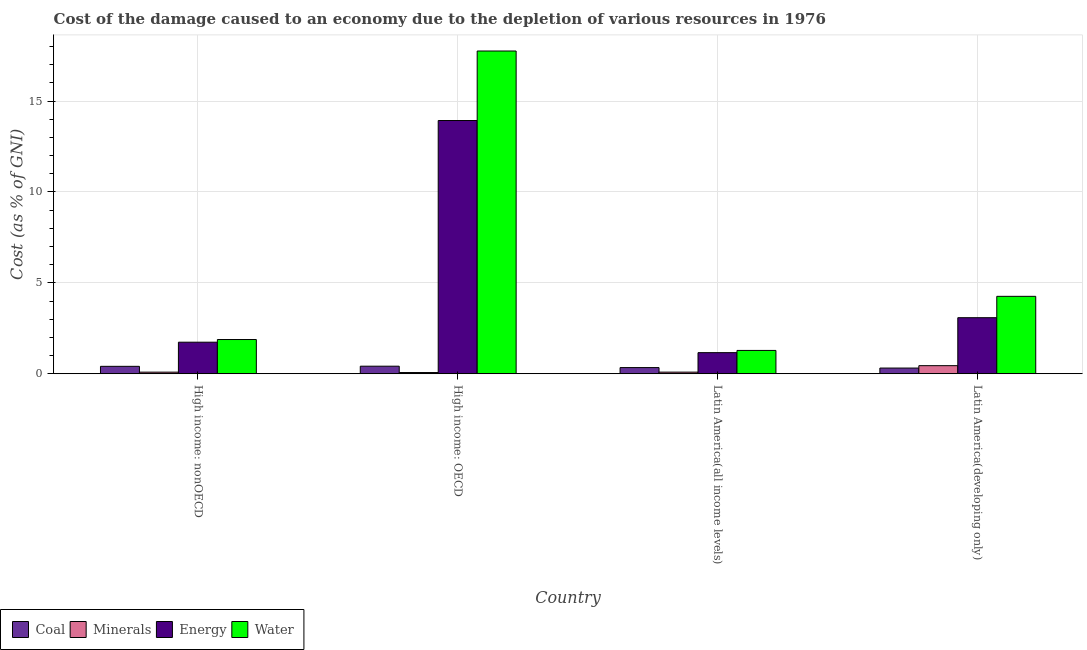How many different coloured bars are there?
Your answer should be very brief. 4. How many bars are there on the 2nd tick from the left?
Keep it short and to the point. 4. What is the label of the 3rd group of bars from the left?
Give a very brief answer. Latin America(all income levels). In how many cases, is the number of bars for a given country not equal to the number of legend labels?
Your answer should be compact. 0. What is the cost of damage due to depletion of water in High income: OECD?
Provide a succinct answer. 17.75. Across all countries, what is the maximum cost of damage due to depletion of minerals?
Ensure brevity in your answer.  0.44. Across all countries, what is the minimum cost of damage due to depletion of energy?
Your response must be concise. 1.16. In which country was the cost of damage due to depletion of coal maximum?
Provide a short and direct response. High income: OECD. In which country was the cost of damage due to depletion of coal minimum?
Give a very brief answer. Latin America(developing only). What is the total cost of damage due to depletion of energy in the graph?
Ensure brevity in your answer.  19.91. What is the difference between the cost of damage due to depletion of energy in High income: nonOECD and that in Latin America(developing only)?
Your answer should be compact. -1.35. What is the difference between the cost of damage due to depletion of energy in High income: OECD and the cost of damage due to depletion of minerals in Latin America(all income levels)?
Ensure brevity in your answer.  13.84. What is the average cost of damage due to depletion of coal per country?
Keep it short and to the point. 0.37. What is the difference between the cost of damage due to depletion of water and cost of damage due to depletion of minerals in High income: OECD?
Provide a succinct answer. 17.69. In how many countries, is the cost of damage due to depletion of water greater than 3 %?
Give a very brief answer. 2. What is the ratio of the cost of damage due to depletion of minerals in High income: OECD to that in Latin America(all income levels)?
Offer a very short reply. 0.74. What is the difference between the highest and the second highest cost of damage due to depletion of energy?
Your answer should be compact. 10.85. What is the difference between the highest and the lowest cost of damage due to depletion of energy?
Give a very brief answer. 12.77. In how many countries, is the cost of damage due to depletion of energy greater than the average cost of damage due to depletion of energy taken over all countries?
Your answer should be very brief. 1. What does the 2nd bar from the left in High income: nonOECD represents?
Your answer should be very brief. Minerals. What does the 4th bar from the right in High income: nonOECD represents?
Ensure brevity in your answer.  Coal. Is it the case that in every country, the sum of the cost of damage due to depletion of coal and cost of damage due to depletion of minerals is greater than the cost of damage due to depletion of energy?
Keep it short and to the point. No. How many countries are there in the graph?
Make the answer very short. 4. Are the values on the major ticks of Y-axis written in scientific E-notation?
Offer a terse response. No. Does the graph contain grids?
Provide a succinct answer. Yes. How are the legend labels stacked?
Your response must be concise. Horizontal. What is the title of the graph?
Offer a very short reply. Cost of the damage caused to an economy due to the depletion of various resources in 1976 . What is the label or title of the Y-axis?
Ensure brevity in your answer.  Cost (as % of GNI). What is the Cost (as % of GNI) of Coal in High income: nonOECD?
Your response must be concise. 0.41. What is the Cost (as % of GNI) in Minerals in High income: nonOECD?
Your answer should be compact. 0.09. What is the Cost (as % of GNI) in Energy in High income: nonOECD?
Your answer should be very brief. 1.73. What is the Cost (as % of GNI) in Water in High income: nonOECD?
Provide a succinct answer. 1.88. What is the Cost (as % of GNI) of Coal in High income: OECD?
Your answer should be very brief. 0.41. What is the Cost (as % of GNI) of Minerals in High income: OECD?
Offer a very short reply. 0.07. What is the Cost (as % of GNI) in Energy in High income: OECD?
Offer a terse response. 13.93. What is the Cost (as % of GNI) of Water in High income: OECD?
Offer a terse response. 17.75. What is the Cost (as % of GNI) in Coal in Latin America(all income levels)?
Keep it short and to the point. 0.34. What is the Cost (as % of GNI) of Minerals in Latin America(all income levels)?
Provide a short and direct response. 0.09. What is the Cost (as % of GNI) of Energy in Latin America(all income levels)?
Provide a short and direct response. 1.16. What is the Cost (as % of GNI) in Water in Latin America(all income levels)?
Make the answer very short. 1.28. What is the Cost (as % of GNI) in Coal in Latin America(developing only)?
Your answer should be compact. 0.31. What is the Cost (as % of GNI) of Minerals in Latin America(developing only)?
Make the answer very short. 0.44. What is the Cost (as % of GNI) in Energy in Latin America(developing only)?
Provide a short and direct response. 3.08. What is the Cost (as % of GNI) in Water in Latin America(developing only)?
Your answer should be compact. 4.26. Across all countries, what is the maximum Cost (as % of GNI) in Coal?
Provide a succinct answer. 0.41. Across all countries, what is the maximum Cost (as % of GNI) in Minerals?
Keep it short and to the point. 0.44. Across all countries, what is the maximum Cost (as % of GNI) of Energy?
Provide a short and direct response. 13.93. Across all countries, what is the maximum Cost (as % of GNI) in Water?
Provide a short and direct response. 17.75. Across all countries, what is the minimum Cost (as % of GNI) of Coal?
Provide a short and direct response. 0.31. Across all countries, what is the minimum Cost (as % of GNI) in Minerals?
Make the answer very short. 0.07. Across all countries, what is the minimum Cost (as % of GNI) of Energy?
Keep it short and to the point. 1.16. Across all countries, what is the minimum Cost (as % of GNI) of Water?
Ensure brevity in your answer.  1.28. What is the total Cost (as % of GNI) of Coal in the graph?
Your response must be concise. 1.47. What is the total Cost (as % of GNI) of Minerals in the graph?
Provide a short and direct response. 0.69. What is the total Cost (as % of GNI) of Energy in the graph?
Give a very brief answer. 19.91. What is the total Cost (as % of GNI) in Water in the graph?
Offer a very short reply. 25.18. What is the difference between the Cost (as % of GNI) of Coal in High income: nonOECD and that in High income: OECD?
Offer a very short reply. -0.01. What is the difference between the Cost (as % of GNI) in Minerals in High income: nonOECD and that in High income: OECD?
Provide a short and direct response. 0.02. What is the difference between the Cost (as % of GNI) in Energy in High income: nonOECD and that in High income: OECD?
Give a very brief answer. -12.19. What is the difference between the Cost (as % of GNI) in Water in High income: nonOECD and that in High income: OECD?
Your answer should be very brief. -15.87. What is the difference between the Cost (as % of GNI) in Coal in High income: nonOECD and that in Latin America(all income levels)?
Offer a very short reply. 0.07. What is the difference between the Cost (as % of GNI) in Minerals in High income: nonOECD and that in Latin America(all income levels)?
Your answer should be compact. -0. What is the difference between the Cost (as % of GNI) of Energy in High income: nonOECD and that in Latin America(all income levels)?
Offer a terse response. 0.57. What is the difference between the Cost (as % of GNI) of Water in High income: nonOECD and that in Latin America(all income levels)?
Make the answer very short. 0.6. What is the difference between the Cost (as % of GNI) in Coal in High income: nonOECD and that in Latin America(developing only)?
Keep it short and to the point. 0.09. What is the difference between the Cost (as % of GNI) in Minerals in High income: nonOECD and that in Latin America(developing only)?
Keep it short and to the point. -0.36. What is the difference between the Cost (as % of GNI) in Energy in High income: nonOECD and that in Latin America(developing only)?
Keep it short and to the point. -1.35. What is the difference between the Cost (as % of GNI) of Water in High income: nonOECD and that in Latin America(developing only)?
Your answer should be very brief. -2.38. What is the difference between the Cost (as % of GNI) in Coal in High income: OECD and that in Latin America(all income levels)?
Give a very brief answer. 0.08. What is the difference between the Cost (as % of GNI) of Minerals in High income: OECD and that in Latin America(all income levels)?
Keep it short and to the point. -0.02. What is the difference between the Cost (as % of GNI) in Energy in High income: OECD and that in Latin America(all income levels)?
Your answer should be very brief. 12.77. What is the difference between the Cost (as % of GNI) of Water in High income: OECD and that in Latin America(all income levels)?
Ensure brevity in your answer.  16.47. What is the difference between the Cost (as % of GNI) in Coal in High income: OECD and that in Latin America(developing only)?
Provide a short and direct response. 0.1. What is the difference between the Cost (as % of GNI) in Minerals in High income: OECD and that in Latin America(developing only)?
Your answer should be very brief. -0.38. What is the difference between the Cost (as % of GNI) of Energy in High income: OECD and that in Latin America(developing only)?
Offer a terse response. 10.85. What is the difference between the Cost (as % of GNI) of Water in High income: OECD and that in Latin America(developing only)?
Your answer should be very brief. 13.5. What is the difference between the Cost (as % of GNI) in Coal in Latin America(all income levels) and that in Latin America(developing only)?
Ensure brevity in your answer.  0.03. What is the difference between the Cost (as % of GNI) of Minerals in Latin America(all income levels) and that in Latin America(developing only)?
Give a very brief answer. -0.36. What is the difference between the Cost (as % of GNI) in Energy in Latin America(all income levels) and that in Latin America(developing only)?
Your answer should be very brief. -1.92. What is the difference between the Cost (as % of GNI) in Water in Latin America(all income levels) and that in Latin America(developing only)?
Make the answer very short. -2.98. What is the difference between the Cost (as % of GNI) of Coal in High income: nonOECD and the Cost (as % of GNI) of Minerals in High income: OECD?
Offer a very short reply. 0.34. What is the difference between the Cost (as % of GNI) of Coal in High income: nonOECD and the Cost (as % of GNI) of Energy in High income: OECD?
Provide a short and direct response. -13.52. What is the difference between the Cost (as % of GNI) in Coal in High income: nonOECD and the Cost (as % of GNI) in Water in High income: OECD?
Provide a short and direct response. -17.35. What is the difference between the Cost (as % of GNI) in Minerals in High income: nonOECD and the Cost (as % of GNI) in Energy in High income: OECD?
Your answer should be very brief. -13.84. What is the difference between the Cost (as % of GNI) in Minerals in High income: nonOECD and the Cost (as % of GNI) in Water in High income: OECD?
Provide a short and direct response. -17.67. What is the difference between the Cost (as % of GNI) in Energy in High income: nonOECD and the Cost (as % of GNI) in Water in High income: OECD?
Offer a very short reply. -16.02. What is the difference between the Cost (as % of GNI) of Coal in High income: nonOECD and the Cost (as % of GNI) of Minerals in Latin America(all income levels)?
Make the answer very short. 0.32. What is the difference between the Cost (as % of GNI) in Coal in High income: nonOECD and the Cost (as % of GNI) in Energy in Latin America(all income levels)?
Ensure brevity in your answer.  -0.75. What is the difference between the Cost (as % of GNI) of Coal in High income: nonOECD and the Cost (as % of GNI) of Water in Latin America(all income levels)?
Offer a terse response. -0.88. What is the difference between the Cost (as % of GNI) in Minerals in High income: nonOECD and the Cost (as % of GNI) in Energy in Latin America(all income levels)?
Give a very brief answer. -1.07. What is the difference between the Cost (as % of GNI) in Minerals in High income: nonOECD and the Cost (as % of GNI) in Water in Latin America(all income levels)?
Offer a very short reply. -1.19. What is the difference between the Cost (as % of GNI) in Energy in High income: nonOECD and the Cost (as % of GNI) in Water in Latin America(all income levels)?
Offer a very short reply. 0.45. What is the difference between the Cost (as % of GNI) of Coal in High income: nonOECD and the Cost (as % of GNI) of Minerals in Latin America(developing only)?
Your answer should be compact. -0.04. What is the difference between the Cost (as % of GNI) in Coal in High income: nonOECD and the Cost (as % of GNI) in Energy in Latin America(developing only)?
Provide a succinct answer. -2.68. What is the difference between the Cost (as % of GNI) of Coal in High income: nonOECD and the Cost (as % of GNI) of Water in Latin America(developing only)?
Offer a very short reply. -3.85. What is the difference between the Cost (as % of GNI) in Minerals in High income: nonOECD and the Cost (as % of GNI) in Energy in Latin America(developing only)?
Offer a terse response. -3. What is the difference between the Cost (as % of GNI) in Minerals in High income: nonOECD and the Cost (as % of GNI) in Water in Latin America(developing only)?
Your answer should be compact. -4.17. What is the difference between the Cost (as % of GNI) in Energy in High income: nonOECD and the Cost (as % of GNI) in Water in Latin America(developing only)?
Your response must be concise. -2.52. What is the difference between the Cost (as % of GNI) of Coal in High income: OECD and the Cost (as % of GNI) of Minerals in Latin America(all income levels)?
Provide a succinct answer. 0.33. What is the difference between the Cost (as % of GNI) in Coal in High income: OECD and the Cost (as % of GNI) in Energy in Latin America(all income levels)?
Provide a short and direct response. -0.75. What is the difference between the Cost (as % of GNI) of Coal in High income: OECD and the Cost (as % of GNI) of Water in Latin America(all income levels)?
Provide a short and direct response. -0.87. What is the difference between the Cost (as % of GNI) in Minerals in High income: OECD and the Cost (as % of GNI) in Energy in Latin America(all income levels)?
Give a very brief answer. -1.09. What is the difference between the Cost (as % of GNI) in Minerals in High income: OECD and the Cost (as % of GNI) in Water in Latin America(all income levels)?
Provide a succinct answer. -1.22. What is the difference between the Cost (as % of GNI) in Energy in High income: OECD and the Cost (as % of GNI) in Water in Latin America(all income levels)?
Offer a very short reply. 12.65. What is the difference between the Cost (as % of GNI) of Coal in High income: OECD and the Cost (as % of GNI) of Minerals in Latin America(developing only)?
Give a very brief answer. -0.03. What is the difference between the Cost (as % of GNI) of Coal in High income: OECD and the Cost (as % of GNI) of Energy in Latin America(developing only)?
Make the answer very short. -2.67. What is the difference between the Cost (as % of GNI) in Coal in High income: OECD and the Cost (as % of GNI) in Water in Latin America(developing only)?
Make the answer very short. -3.84. What is the difference between the Cost (as % of GNI) in Minerals in High income: OECD and the Cost (as % of GNI) in Energy in Latin America(developing only)?
Ensure brevity in your answer.  -3.02. What is the difference between the Cost (as % of GNI) of Minerals in High income: OECD and the Cost (as % of GNI) of Water in Latin America(developing only)?
Keep it short and to the point. -4.19. What is the difference between the Cost (as % of GNI) of Energy in High income: OECD and the Cost (as % of GNI) of Water in Latin America(developing only)?
Make the answer very short. 9.67. What is the difference between the Cost (as % of GNI) of Coal in Latin America(all income levels) and the Cost (as % of GNI) of Minerals in Latin America(developing only)?
Make the answer very short. -0.11. What is the difference between the Cost (as % of GNI) in Coal in Latin America(all income levels) and the Cost (as % of GNI) in Energy in Latin America(developing only)?
Keep it short and to the point. -2.74. What is the difference between the Cost (as % of GNI) of Coal in Latin America(all income levels) and the Cost (as % of GNI) of Water in Latin America(developing only)?
Provide a succinct answer. -3.92. What is the difference between the Cost (as % of GNI) of Minerals in Latin America(all income levels) and the Cost (as % of GNI) of Energy in Latin America(developing only)?
Your answer should be very brief. -2.99. What is the difference between the Cost (as % of GNI) in Minerals in Latin America(all income levels) and the Cost (as % of GNI) in Water in Latin America(developing only)?
Your response must be concise. -4.17. What is the difference between the Cost (as % of GNI) of Energy in Latin America(all income levels) and the Cost (as % of GNI) of Water in Latin America(developing only)?
Make the answer very short. -3.1. What is the average Cost (as % of GNI) in Coal per country?
Make the answer very short. 0.37. What is the average Cost (as % of GNI) in Minerals per country?
Provide a succinct answer. 0.17. What is the average Cost (as % of GNI) in Energy per country?
Offer a terse response. 4.98. What is the average Cost (as % of GNI) of Water per country?
Ensure brevity in your answer.  6.29. What is the difference between the Cost (as % of GNI) of Coal and Cost (as % of GNI) of Minerals in High income: nonOECD?
Your answer should be compact. 0.32. What is the difference between the Cost (as % of GNI) in Coal and Cost (as % of GNI) in Energy in High income: nonOECD?
Ensure brevity in your answer.  -1.33. What is the difference between the Cost (as % of GNI) of Coal and Cost (as % of GNI) of Water in High income: nonOECD?
Make the answer very short. -1.47. What is the difference between the Cost (as % of GNI) of Minerals and Cost (as % of GNI) of Energy in High income: nonOECD?
Offer a very short reply. -1.65. What is the difference between the Cost (as % of GNI) in Minerals and Cost (as % of GNI) in Water in High income: nonOECD?
Keep it short and to the point. -1.79. What is the difference between the Cost (as % of GNI) of Energy and Cost (as % of GNI) of Water in High income: nonOECD?
Provide a short and direct response. -0.15. What is the difference between the Cost (as % of GNI) of Coal and Cost (as % of GNI) of Minerals in High income: OECD?
Make the answer very short. 0.35. What is the difference between the Cost (as % of GNI) in Coal and Cost (as % of GNI) in Energy in High income: OECD?
Provide a succinct answer. -13.52. What is the difference between the Cost (as % of GNI) in Coal and Cost (as % of GNI) in Water in High income: OECD?
Ensure brevity in your answer.  -17.34. What is the difference between the Cost (as % of GNI) in Minerals and Cost (as % of GNI) in Energy in High income: OECD?
Offer a terse response. -13.86. What is the difference between the Cost (as % of GNI) of Minerals and Cost (as % of GNI) of Water in High income: OECD?
Offer a very short reply. -17.69. What is the difference between the Cost (as % of GNI) in Energy and Cost (as % of GNI) in Water in High income: OECD?
Offer a terse response. -3.82. What is the difference between the Cost (as % of GNI) in Coal and Cost (as % of GNI) in Minerals in Latin America(all income levels)?
Give a very brief answer. 0.25. What is the difference between the Cost (as % of GNI) in Coal and Cost (as % of GNI) in Energy in Latin America(all income levels)?
Your response must be concise. -0.82. What is the difference between the Cost (as % of GNI) in Coal and Cost (as % of GNI) in Water in Latin America(all income levels)?
Offer a very short reply. -0.94. What is the difference between the Cost (as % of GNI) of Minerals and Cost (as % of GNI) of Energy in Latin America(all income levels)?
Make the answer very short. -1.07. What is the difference between the Cost (as % of GNI) of Minerals and Cost (as % of GNI) of Water in Latin America(all income levels)?
Your response must be concise. -1.19. What is the difference between the Cost (as % of GNI) in Energy and Cost (as % of GNI) in Water in Latin America(all income levels)?
Give a very brief answer. -0.12. What is the difference between the Cost (as % of GNI) of Coal and Cost (as % of GNI) of Minerals in Latin America(developing only)?
Give a very brief answer. -0.13. What is the difference between the Cost (as % of GNI) in Coal and Cost (as % of GNI) in Energy in Latin America(developing only)?
Provide a succinct answer. -2.77. What is the difference between the Cost (as % of GNI) of Coal and Cost (as % of GNI) of Water in Latin America(developing only)?
Keep it short and to the point. -3.95. What is the difference between the Cost (as % of GNI) in Minerals and Cost (as % of GNI) in Energy in Latin America(developing only)?
Give a very brief answer. -2.64. What is the difference between the Cost (as % of GNI) in Minerals and Cost (as % of GNI) in Water in Latin America(developing only)?
Ensure brevity in your answer.  -3.81. What is the difference between the Cost (as % of GNI) in Energy and Cost (as % of GNI) in Water in Latin America(developing only)?
Keep it short and to the point. -1.18. What is the ratio of the Cost (as % of GNI) of Coal in High income: nonOECD to that in High income: OECD?
Your answer should be compact. 0.98. What is the ratio of the Cost (as % of GNI) in Minerals in High income: nonOECD to that in High income: OECD?
Give a very brief answer. 1.33. What is the ratio of the Cost (as % of GNI) in Energy in High income: nonOECD to that in High income: OECD?
Your answer should be very brief. 0.12. What is the ratio of the Cost (as % of GNI) of Water in High income: nonOECD to that in High income: OECD?
Offer a very short reply. 0.11. What is the ratio of the Cost (as % of GNI) of Coal in High income: nonOECD to that in Latin America(all income levels)?
Keep it short and to the point. 1.2. What is the ratio of the Cost (as % of GNI) in Minerals in High income: nonOECD to that in Latin America(all income levels)?
Keep it short and to the point. 0.99. What is the ratio of the Cost (as % of GNI) in Energy in High income: nonOECD to that in Latin America(all income levels)?
Offer a terse response. 1.5. What is the ratio of the Cost (as % of GNI) in Water in High income: nonOECD to that in Latin America(all income levels)?
Offer a very short reply. 1.47. What is the ratio of the Cost (as % of GNI) in Coal in High income: nonOECD to that in Latin America(developing only)?
Keep it short and to the point. 1.3. What is the ratio of the Cost (as % of GNI) of Minerals in High income: nonOECD to that in Latin America(developing only)?
Your answer should be compact. 0.2. What is the ratio of the Cost (as % of GNI) in Energy in High income: nonOECD to that in Latin America(developing only)?
Ensure brevity in your answer.  0.56. What is the ratio of the Cost (as % of GNI) in Water in High income: nonOECD to that in Latin America(developing only)?
Offer a very short reply. 0.44. What is the ratio of the Cost (as % of GNI) of Coal in High income: OECD to that in Latin America(all income levels)?
Your answer should be very brief. 1.22. What is the ratio of the Cost (as % of GNI) in Minerals in High income: OECD to that in Latin America(all income levels)?
Offer a terse response. 0.74. What is the ratio of the Cost (as % of GNI) in Energy in High income: OECD to that in Latin America(all income levels)?
Provide a succinct answer. 12.01. What is the ratio of the Cost (as % of GNI) of Water in High income: OECD to that in Latin America(all income levels)?
Your answer should be compact. 13.84. What is the ratio of the Cost (as % of GNI) in Coal in High income: OECD to that in Latin America(developing only)?
Ensure brevity in your answer.  1.33. What is the ratio of the Cost (as % of GNI) of Minerals in High income: OECD to that in Latin America(developing only)?
Your response must be concise. 0.15. What is the ratio of the Cost (as % of GNI) of Energy in High income: OECD to that in Latin America(developing only)?
Your answer should be very brief. 4.52. What is the ratio of the Cost (as % of GNI) in Water in High income: OECD to that in Latin America(developing only)?
Offer a very short reply. 4.17. What is the ratio of the Cost (as % of GNI) of Coal in Latin America(all income levels) to that in Latin America(developing only)?
Give a very brief answer. 1.08. What is the ratio of the Cost (as % of GNI) in Minerals in Latin America(all income levels) to that in Latin America(developing only)?
Ensure brevity in your answer.  0.2. What is the ratio of the Cost (as % of GNI) in Energy in Latin America(all income levels) to that in Latin America(developing only)?
Provide a short and direct response. 0.38. What is the ratio of the Cost (as % of GNI) of Water in Latin America(all income levels) to that in Latin America(developing only)?
Make the answer very short. 0.3. What is the difference between the highest and the second highest Cost (as % of GNI) of Coal?
Give a very brief answer. 0.01. What is the difference between the highest and the second highest Cost (as % of GNI) of Minerals?
Your answer should be very brief. 0.36. What is the difference between the highest and the second highest Cost (as % of GNI) of Energy?
Your answer should be compact. 10.85. What is the difference between the highest and the second highest Cost (as % of GNI) of Water?
Offer a terse response. 13.5. What is the difference between the highest and the lowest Cost (as % of GNI) of Coal?
Ensure brevity in your answer.  0.1. What is the difference between the highest and the lowest Cost (as % of GNI) in Minerals?
Offer a terse response. 0.38. What is the difference between the highest and the lowest Cost (as % of GNI) in Energy?
Make the answer very short. 12.77. What is the difference between the highest and the lowest Cost (as % of GNI) of Water?
Offer a terse response. 16.47. 